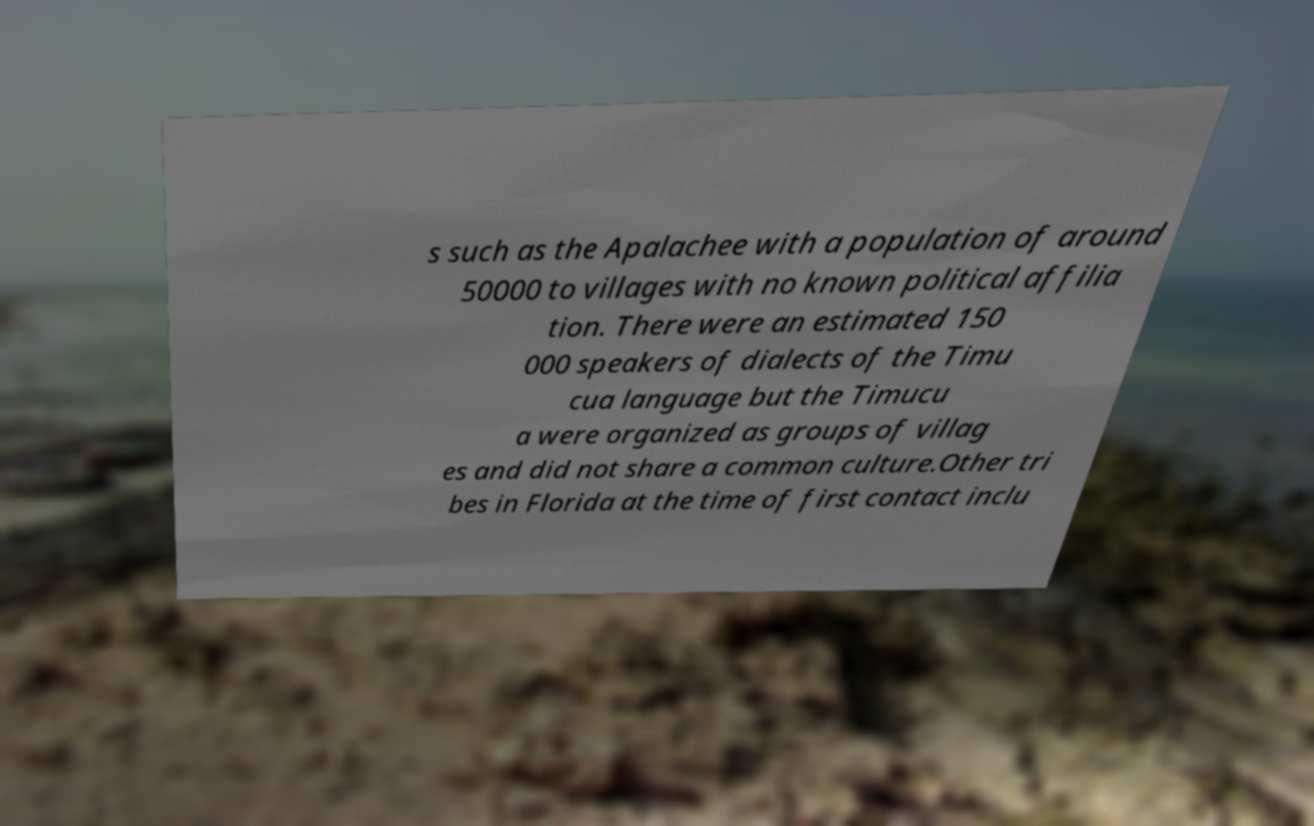There's text embedded in this image that I need extracted. Can you transcribe it verbatim? s such as the Apalachee with a population of around 50000 to villages with no known political affilia tion. There were an estimated 150 000 speakers of dialects of the Timu cua language but the Timucu a were organized as groups of villag es and did not share a common culture.Other tri bes in Florida at the time of first contact inclu 